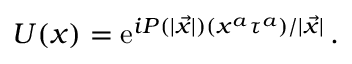<formula> <loc_0><loc_0><loc_500><loc_500>U ( x ) = e ^ { i P ( | { \vec { x } } | ) ( x ^ { a } \tau ^ { a } ) / | { \vec { x } } | } \, .</formula> 